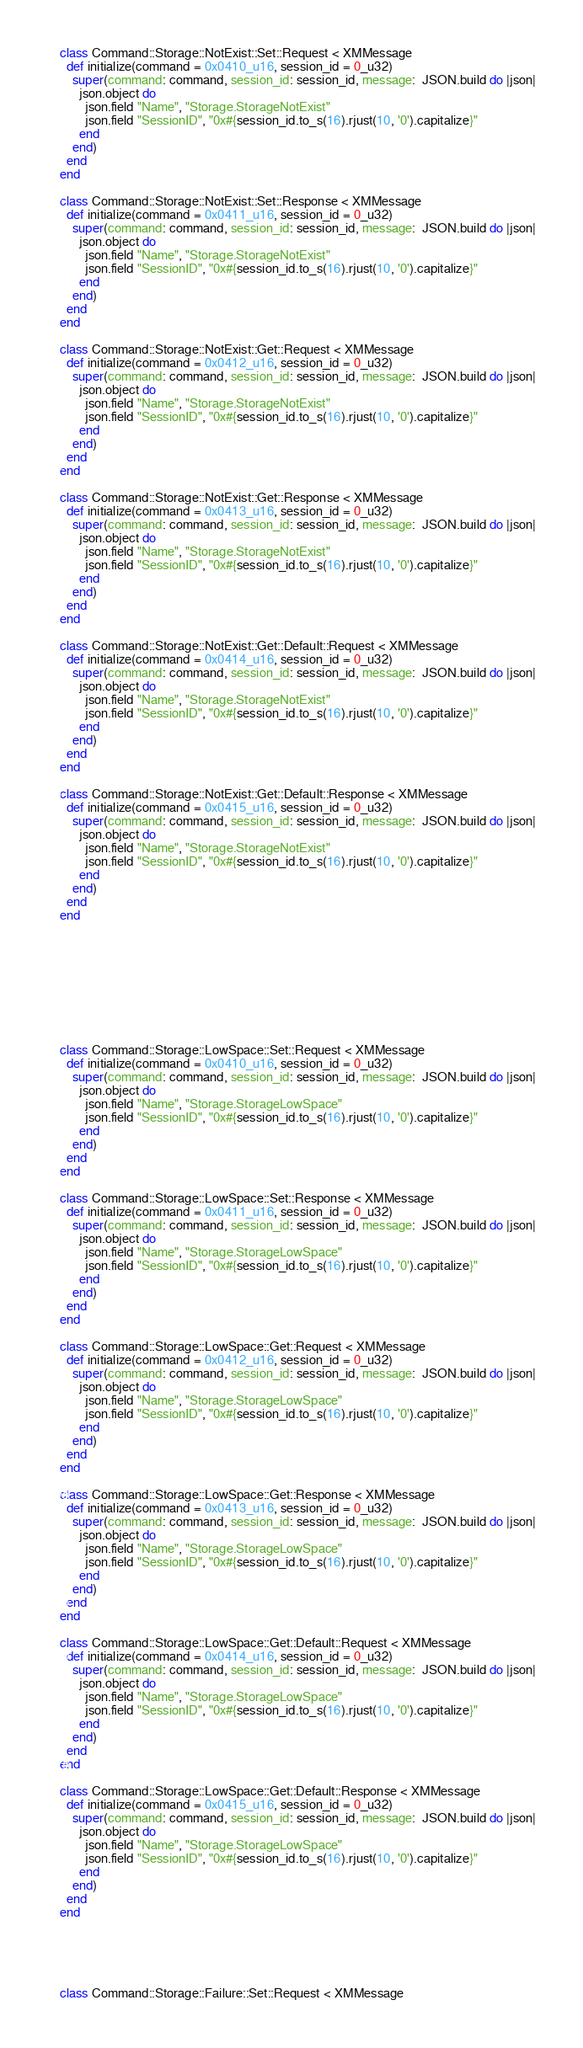<code> <loc_0><loc_0><loc_500><loc_500><_Crystal_>class Command::Storage::NotExist::Set::Request < XMMessage
  def initialize(command = 0x0410_u16, session_id = 0_u32)
    super(command: command, session_id: session_id, message:  JSON.build do |json|
      json.object do
        json.field "Name", "Storage.StorageNotExist"
        json.field "SessionID", "0x#{session_id.to_s(16).rjust(10, '0').capitalize}"
      end
    end)
  end
end

class Command::Storage::NotExist::Set::Response < XMMessage
  def initialize(command = 0x0411_u16, session_id = 0_u32)
    super(command: command, session_id: session_id, message:  JSON.build do |json|
      json.object do
        json.field "Name", "Storage.StorageNotExist"
        json.field "SessionID", "0x#{session_id.to_s(16).rjust(10, '0').capitalize}"
      end
    end)
  end
end

class Command::Storage::NotExist::Get::Request < XMMessage
  def initialize(command = 0x0412_u16, session_id = 0_u32)
    super(command: command, session_id: session_id, message:  JSON.build do |json|
      json.object do
        json.field "Name", "Storage.StorageNotExist"
        json.field "SessionID", "0x#{session_id.to_s(16).rjust(10, '0').capitalize}"
      end
    end)
  end
end

class Command::Storage::NotExist::Get::Response < XMMessage
  def initialize(command = 0x0413_u16, session_id = 0_u32)
    super(command: command, session_id: session_id, message:  JSON.build do |json|
      json.object do
        json.field "Name", "Storage.StorageNotExist"
        json.field "SessionID", "0x#{session_id.to_s(16).rjust(10, '0').capitalize}"
      end
    end)
  end
end

class Command::Storage::NotExist::Get::Default::Request < XMMessage
  def initialize(command = 0x0414_u16, session_id = 0_u32)
    super(command: command, session_id: session_id, message:  JSON.build do |json|
      json.object do
        json.field "Name", "Storage.StorageNotExist"
        json.field "SessionID", "0x#{session_id.to_s(16).rjust(10, '0').capitalize}"
      end
    end)
  end
end

class Command::Storage::NotExist::Get::Default::Response < XMMessage
  def initialize(command = 0x0415_u16, session_id = 0_u32)
    super(command: command, session_id: session_id, message:  JSON.build do |json|
      json.object do
        json.field "Name", "Storage.StorageNotExist"
        json.field "SessionID", "0x#{session_id.to_s(16).rjust(10, '0').capitalize}"
      end
    end)
  end
end









class Command::Storage::LowSpace::Set::Request < XMMessage
  def initialize(command = 0x0410_u16, session_id = 0_u32)
    super(command: command, session_id: session_id, message:  JSON.build do |json|
      json.object do
        json.field "Name", "Storage.StorageLowSpace"
        json.field "SessionID", "0x#{session_id.to_s(16).rjust(10, '0').capitalize}"
      end
    end)
  end
end

class Command::Storage::LowSpace::Set::Response < XMMessage
  def initialize(command = 0x0411_u16, session_id = 0_u32)
    super(command: command, session_id: session_id, message:  JSON.build do |json|
      json.object do
        json.field "Name", "Storage.StorageLowSpace"
        json.field "SessionID", "0x#{session_id.to_s(16).rjust(10, '0').capitalize}"
      end
    end)
  end
end

class Command::Storage::LowSpace::Get::Request < XMMessage
  def initialize(command = 0x0412_u16, session_id = 0_u32)
    super(command: command, session_id: session_id, message:  JSON.build do |json|
      json.object do
        json.field "Name", "Storage.StorageLowSpace"
        json.field "SessionID", "0x#{session_id.to_s(16).rjust(10, '0').capitalize}"
      end
    end)
  end
end

class Command::Storage::LowSpace::Get::Response < XMMessage
  def initialize(command = 0x0413_u16, session_id = 0_u32)
    super(command: command, session_id: session_id, message:  JSON.build do |json|
      json.object do
        json.field "Name", "Storage.StorageLowSpace"
        json.field "SessionID", "0x#{session_id.to_s(16).rjust(10, '0').capitalize}"
      end
    end)
  end
end

class Command::Storage::LowSpace::Get::Default::Request < XMMessage
  def initialize(command = 0x0414_u16, session_id = 0_u32)
    super(command: command, session_id: session_id, message:  JSON.build do |json|
      json.object do
        json.field "Name", "Storage.StorageLowSpace"
        json.field "SessionID", "0x#{session_id.to_s(16).rjust(10, '0').capitalize}"
      end
    end)
  end
end

class Command::Storage::LowSpace::Get::Default::Response < XMMessage
  def initialize(command = 0x0415_u16, session_id = 0_u32)
    super(command: command, session_id: session_id, message:  JSON.build do |json|
      json.object do
        json.field "Name", "Storage.StorageLowSpace"
        json.field "SessionID", "0x#{session_id.to_s(16).rjust(10, '0').capitalize}"
      end
    end)
  end
end





class Command::Storage::Failure::Set::Request < XMMessage</code> 